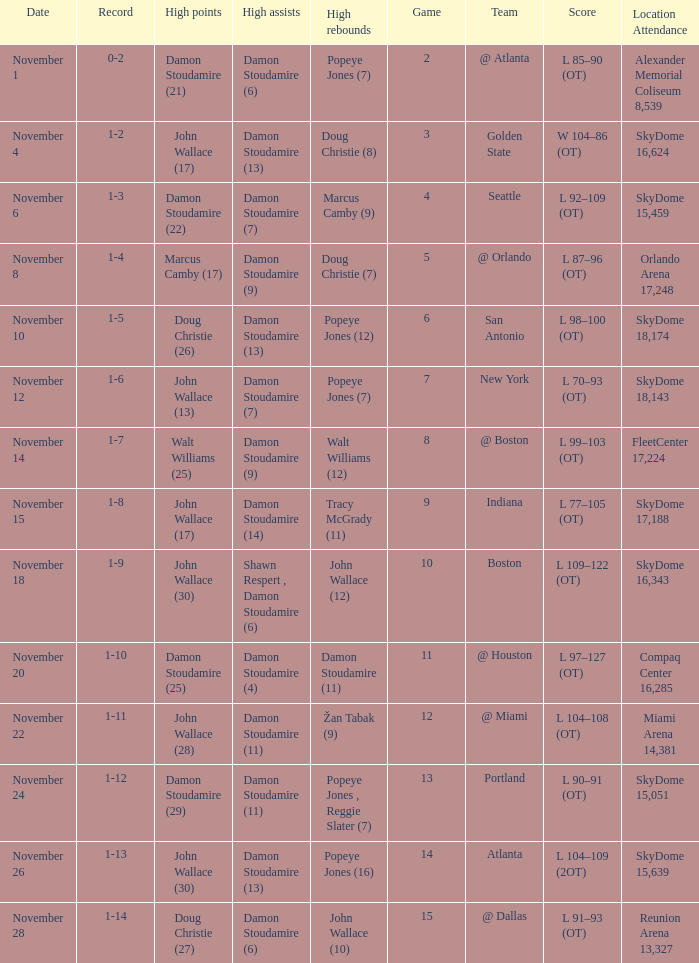What was the score against san antonio? L 98–100 (OT). 